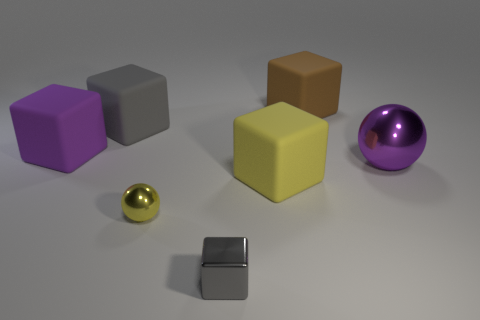What can you tell me about the color palette visible in this scene? The color palette of this scene is varied but fairly muted, featuring pastel shades like light purple, soft yellow, and grey. These subdued hues give the scene a calm, harmonious feel, and the inclusion of the vibrant purple ball adds a pop of contrast that draws the eye. 